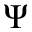Convert formula to latex. <formula><loc_0><loc_0><loc_500><loc_500>\Psi</formula> 